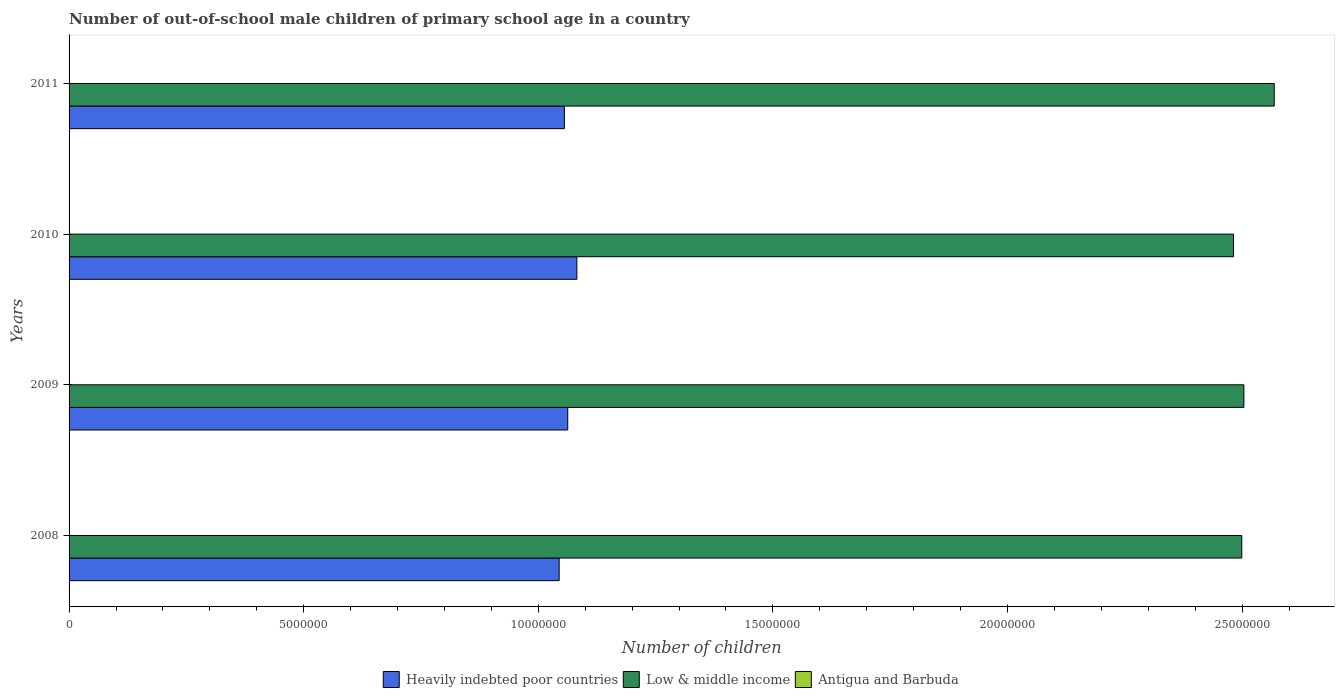How many groups of bars are there?
Your response must be concise. 4. Are the number of bars per tick equal to the number of legend labels?
Make the answer very short. Yes. Are the number of bars on each tick of the Y-axis equal?
Offer a very short reply. Yes. How many bars are there on the 3rd tick from the bottom?
Ensure brevity in your answer.  3. What is the label of the 1st group of bars from the top?
Your answer should be compact. 2011. In how many cases, is the number of bars for a given year not equal to the number of legend labels?
Your response must be concise. 0. What is the number of out-of-school male children in Heavily indebted poor countries in 2008?
Give a very brief answer. 1.04e+07. Across all years, what is the maximum number of out-of-school male children in Antigua and Barbuda?
Your answer should be compact. 570. Across all years, what is the minimum number of out-of-school male children in Antigua and Barbuda?
Offer a terse response. 345. What is the total number of out-of-school male children in Antigua and Barbuda in the graph?
Provide a succinct answer. 1701. What is the difference between the number of out-of-school male children in Heavily indebted poor countries in 2010 and that in 2011?
Your response must be concise. 2.66e+05. What is the difference between the number of out-of-school male children in Low & middle income in 2009 and the number of out-of-school male children in Heavily indebted poor countries in 2008?
Your answer should be compact. 1.46e+07. What is the average number of out-of-school male children in Low & middle income per year?
Provide a short and direct response. 2.51e+07. In the year 2010, what is the difference between the number of out-of-school male children in Antigua and Barbuda and number of out-of-school male children in Low & middle income?
Provide a succinct answer. -2.48e+07. In how many years, is the number of out-of-school male children in Heavily indebted poor countries greater than 4000000 ?
Ensure brevity in your answer.  4. What is the ratio of the number of out-of-school male children in Heavily indebted poor countries in 2008 to that in 2009?
Offer a terse response. 0.98. Is the number of out-of-school male children in Antigua and Barbuda in 2008 less than that in 2011?
Offer a terse response. Yes. What is the difference between the highest and the second highest number of out-of-school male children in Low & middle income?
Give a very brief answer. 6.47e+05. What is the difference between the highest and the lowest number of out-of-school male children in Antigua and Barbuda?
Keep it short and to the point. 225. In how many years, is the number of out-of-school male children in Low & middle income greater than the average number of out-of-school male children in Low & middle income taken over all years?
Make the answer very short. 1. What does the 1st bar from the top in 2009 represents?
Keep it short and to the point. Antigua and Barbuda. What does the 3rd bar from the bottom in 2009 represents?
Give a very brief answer. Antigua and Barbuda. Is it the case that in every year, the sum of the number of out-of-school male children in Heavily indebted poor countries and number of out-of-school male children in Low & middle income is greater than the number of out-of-school male children in Antigua and Barbuda?
Provide a short and direct response. Yes. Are all the bars in the graph horizontal?
Offer a terse response. Yes. How many years are there in the graph?
Provide a succinct answer. 4. Are the values on the major ticks of X-axis written in scientific E-notation?
Offer a terse response. No. Does the graph contain grids?
Offer a terse response. No. Where does the legend appear in the graph?
Provide a succinct answer. Bottom center. How are the legend labels stacked?
Provide a succinct answer. Horizontal. What is the title of the graph?
Offer a very short reply. Number of out-of-school male children of primary school age in a country. What is the label or title of the X-axis?
Your answer should be very brief. Number of children. What is the label or title of the Y-axis?
Offer a very short reply. Years. What is the Number of children of Heavily indebted poor countries in 2008?
Keep it short and to the point. 1.04e+07. What is the Number of children in Low & middle income in 2008?
Make the answer very short. 2.50e+07. What is the Number of children in Antigua and Barbuda in 2008?
Your answer should be very brief. 394. What is the Number of children in Heavily indebted poor countries in 2009?
Give a very brief answer. 1.06e+07. What is the Number of children of Low & middle income in 2009?
Make the answer very short. 2.50e+07. What is the Number of children of Antigua and Barbuda in 2009?
Your response must be concise. 345. What is the Number of children in Heavily indebted poor countries in 2010?
Your answer should be compact. 1.08e+07. What is the Number of children of Low & middle income in 2010?
Offer a terse response. 2.48e+07. What is the Number of children in Antigua and Barbuda in 2010?
Ensure brevity in your answer.  392. What is the Number of children of Heavily indebted poor countries in 2011?
Your response must be concise. 1.06e+07. What is the Number of children of Low & middle income in 2011?
Offer a terse response. 2.57e+07. What is the Number of children in Antigua and Barbuda in 2011?
Keep it short and to the point. 570. Across all years, what is the maximum Number of children in Heavily indebted poor countries?
Offer a terse response. 1.08e+07. Across all years, what is the maximum Number of children of Low & middle income?
Offer a terse response. 2.57e+07. Across all years, what is the maximum Number of children of Antigua and Barbuda?
Provide a succinct answer. 570. Across all years, what is the minimum Number of children of Heavily indebted poor countries?
Offer a very short reply. 1.04e+07. Across all years, what is the minimum Number of children of Low & middle income?
Offer a very short reply. 2.48e+07. Across all years, what is the minimum Number of children of Antigua and Barbuda?
Provide a short and direct response. 345. What is the total Number of children of Heavily indebted poor countries in the graph?
Keep it short and to the point. 4.25e+07. What is the total Number of children of Low & middle income in the graph?
Your answer should be very brief. 1.01e+08. What is the total Number of children in Antigua and Barbuda in the graph?
Your answer should be compact. 1701. What is the difference between the Number of children of Heavily indebted poor countries in 2008 and that in 2009?
Your answer should be compact. -1.83e+05. What is the difference between the Number of children in Low & middle income in 2008 and that in 2009?
Your answer should be compact. -4.48e+04. What is the difference between the Number of children in Heavily indebted poor countries in 2008 and that in 2010?
Offer a terse response. -3.77e+05. What is the difference between the Number of children of Low & middle income in 2008 and that in 2010?
Your answer should be very brief. 1.77e+05. What is the difference between the Number of children of Antigua and Barbuda in 2008 and that in 2010?
Your answer should be very brief. 2. What is the difference between the Number of children of Heavily indebted poor countries in 2008 and that in 2011?
Provide a succinct answer. -1.11e+05. What is the difference between the Number of children in Low & middle income in 2008 and that in 2011?
Your answer should be compact. -6.91e+05. What is the difference between the Number of children in Antigua and Barbuda in 2008 and that in 2011?
Offer a very short reply. -176. What is the difference between the Number of children of Heavily indebted poor countries in 2009 and that in 2010?
Offer a terse response. -1.95e+05. What is the difference between the Number of children in Low & middle income in 2009 and that in 2010?
Your answer should be very brief. 2.22e+05. What is the difference between the Number of children of Antigua and Barbuda in 2009 and that in 2010?
Your answer should be compact. -47. What is the difference between the Number of children in Heavily indebted poor countries in 2009 and that in 2011?
Give a very brief answer. 7.16e+04. What is the difference between the Number of children in Low & middle income in 2009 and that in 2011?
Keep it short and to the point. -6.47e+05. What is the difference between the Number of children in Antigua and Barbuda in 2009 and that in 2011?
Provide a succinct answer. -225. What is the difference between the Number of children of Heavily indebted poor countries in 2010 and that in 2011?
Make the answer very short. 2.66e+05. What is the difference between the Number of children of Low & middle income in 2010 and that in 2011?
Offer a very short reply. -8.68e+05. What is the difference between the Number of children in Antigua and Barbuda in 2010 and that in 2011?
Make the answer very short. -178. What is the difference between the Number of children in Heavily indebted poor countries in 2008 and the Number of children in Low & middle income in 2009?
Your answer should be very brief. -1.46e+07. What is the difference between the Number of children of Heavily indebted poor countries in 2008 and the Number of children of Antigua and Barbuda in 2009?
Make the answer very short. 1.04e+07. What is the difference between the Number of children of Low & middle income in 2008 and the Number of children of Antigua and Barbuda in 2009?
Offer a terse response. 2.50e+07. What is the difference between the Number of children of Heavily indebted poor countries in 2008 and the Number of children of Low & middle income in 2010?
Ensure brevity in your answer.  -1.44e+07. What is the difference between the Number of children in Heavily indebted poor countries in 2008 and the Number of children in Antigua and Barbuda in 2010?
Keep it short and to the point. 1.04e+07. What is the difference between the Number of children of Low & middle income in 2008 and the Number of children of Antigua and Barbuda in 2010?
Provide a succinct answer. 2.50e+07. What is the difference between the Number of children of Heavily indebted poor countries in 2008 and the Number of children of Low & middle income in 2011?
Keep it short and to the point. -1.52e+07. What is the difference between the Number of children of Heavily indebted poor countries in 2008 and the Number of children of Antigua and Barbuda in 2011?
Keep it short and to the point. 1.04e+07. What is the difference between the Number of children of Low & middle income in 2008 and the Number of children of Antigua and Barbuda in 2011?
Give a very brief answer. 2.50e+07. What is the difference between the Number of children in Heavily indebted poor countries in 2009 and the Number of children in Low & middle income in 2010?
Give a very brief answer. -1.42e+07. What is the difference between the Number of children of Heavily indebted poor countries in 2009 and the Number of children of Antigua and Barbuda in 2010?
Provide a short and direct response. 1.06e+07. What is the difference between the Number of children in Low & middle income in 2009 and the Number of children in Antigua and Barbuda in 2010?
Provide a succinct answer. 2.50e+07. What is the difference between the Number of children of Heavily indebted poor countries in 2009 and the Number of children of Low & middle income in 2011?
Offer a terse response. -1.51e+07. What is the difference between the Number of children of Heavily indebted poor countries in 2009 and the Number of children of Antigua and Barbuda in 2011?
Provide a succinct answer. 1.06e+07. What is the difference between the Number of children of Low & middle income in 2009 and the Number of children of Antigua and Barbuda in 2011?
Your answer should be compact. 2.50e+07. What is the difference between the Number of children of Heavily indebted poor countries in 2010 and the Number of children of Low & middle income in 2011?
Provide a short and direct response. -1.49e+07. What is the difference between the Number of children in Heavily indebted poor countries in 2010 and the Number of children in Antigua and Barbuda in 2011?
Ensure brevity in your answer.  1.08e+07. What is the difference between the Number of children of Low & middle income in 2010 and the Number of children of Antigua and Barbuda in 2011?
Offer a very short reply. 2.48e+07. What is the average Number of children of Heavily indebted poor countries per year?
Your answer should be compact. 1.06e+07. What is the average Number of children in Low & middle income per year?
Offer a very short reply. 2.51e+07. What is the average Number of children in Antigua and Barbuda per year?
Your answer should be compact. 425.25. In the year 2008, what is the difference between the Number of children in Heavily indebted poor countries and Number of children in Low & middle income?
Make the answer very short. -1.45e+07. In the year 2008, what is the difference between the Number of children in Heavily indebted poor countries and Number of children in Antigua and Barbuda?
Offer a terse response. 1.04e+07. In the year 2008, what is the difference between the Number of children in Low & middle income and Number of children in Antigua and Barbuda?
Give a very brief answer. 2.50e+07. In the year 2009, what is the difference between the Number of children in Heavily indebted poor countries and Number of children in Low & middle income?
Provide a short and direct response. -1.44e+07. In the year 2009, what is the difference between the Number of children in Heavily indebted poor countries and Number of children in Antigua and Barbuda?
Give a very brief answer. 1.06e+07. In the year 2009, what is the difference between the Number of children in Low & middle income and Number of children in Antigua and Barbuda?
Your answer should be very brief. 2.50e+07. In the year 2010, what is the difference between the Number of children of Heavily indebted poor countries and Number of children of Low & middle income?
Provide a succinct answer. -1.40e+07. In the year 2010, what is the difference between the Number of children of Heavily indebted poor countries and Number of children of Antigua and Barbuda?
Make the answer very short. 1.08e+07. In the year 2010, what is the difference between the Number of children of Low & middle income and Number of children of Antigua and Barbuda?
Your answer should be compact. 2.48e+07. In the year 2011, what is the difference between the Number of children in Heavily indebted poor countries and Number of children in Low & middle income?
Your response must be concise. -1.51e+07. In the year 2011, what is the difference between the Number of children in Heavily indebted poor countries and Number of children in Antigua and Barbuda?
Your response must be concise. 1.06e+07. In the year 2011, what is the difference between the Number of children in Low & middle income and Number of children in Antigua and Barbuda?
Provide a short and direct response. 2.57e+07. What is the ratio of the Number of children in Heavily indebted poor countries in 2008 to that in 2009?
Provide a short and direct response. 0.98. What is the ratio of the Number of children in Low & middle income in 2008 to that in 2009?
Offer a terse response. 1. What is the ratio of the Number of children of Antigua and Barbuda in 2008 to that in 2009?
Your answer should be compact. 1.14. What is the ratio of the Number of children of Heavily indebted poor countries in 2008 to that in 2010?
Make the answer very short. 0.97. What is the ratio of the Number of children of Low & middle income in 2008 to that in 2010?
Keep it short and to the point. 1.01. What is the ratio of the Number of children in Antigua and Barbuda in 2008 to that in 2010?
Keep it short and to the point. 1.01. What is the ratio of the Number of children in Heavily indebted poor countries in 2008 to that in 2011?
Your response must be concise. 0.99. What is the ratio of the Number of children of Low & middle income in 2008 to that in 2011?
Your response must be concise. 0.97. What is the ratio of the Number of children of Antigua and Barbuda in 2008 to that in 2011?
Ensure brevity in your answer.  0.69. What is the ratio of the Number of children of Low & middle income in 2009 to that in 2010?
Offer a very short reply. 1.01. What is the ratio of the Number of children in Antigua and Barbuda in 2009 to that in 2010?
Ensure brevity in your answer.  0.88. What is the ratio of the Number of children in Heavily indebted poor countries in 2009 to that in 2011?
Your answer should be very brief. 1.01. What is the ratio of the Number of children of Low & middle income in 2009 to that in 2011?
Ensure brevity in your answer.  0.97. What is the ratio of the Number of children in Antigua and Barbuda in 2009 to that in 2011?
Make the answer very short. 0.61. What is the ratio of the Number of children of Heavily indebted poor countries in 2010 to that in 2011?
Ensure brevity in your answer.  1.03. What is the ratio of the Number of children of Low & middle income in 2010 to that in 2011?
Your response must be concise. 0.97. What is the ratio of the Number of children of Antigua and Barbuda in 2010 to that in 2011?
Provide a succinct answer. 0.69. What is the difference between the highest and the second highest Number of children of Heavily indebted poor countries?
Provide a succinct answer. 1.95e+05. What is the difference between the highest and the second highest Number of children of Low & middle income?
Provide a short and direct response. 6.47e+05. What is the difference between the highest and the second highest Number of children of Antigua and Barbuda?
Give a very brief answer. 176. What is the difference between the highest and the lowest Number of children of Heavily indebted poor countries?
Provide a short and direct response. 3.77e+05. What is the difference between the highest and the lowest Number of children of Low & middle income?
Keep it short and to the point. 8.68e+05. What is the difference between the highest and the lowest Number of children of Antigua and Barbuda?
Offer a very short reply. 225. 